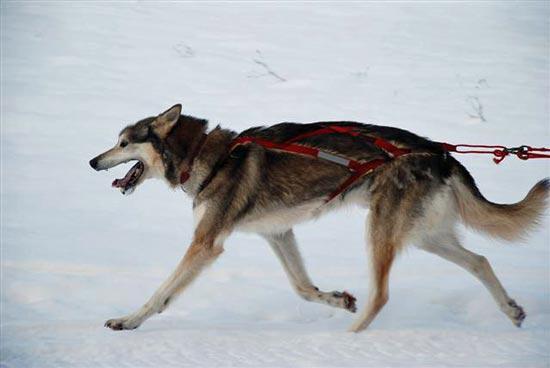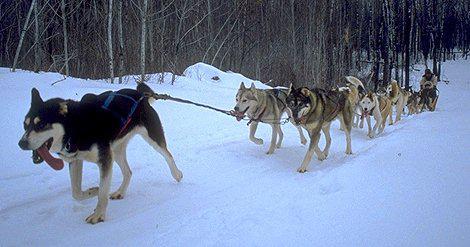The first image is the image on the left, the second image is the image on the right. Considering the images on both sides, is "An image shows a multicolored dog wearing a red harness that extends out of the snowy scene." valid? Answer yes or no. Yes. The first image is the image on the left, the second image is the image on the right. For the images displayed, is the sentence "The left image contains exactly one dog." factually correct? Answer yes or no. Yes. 